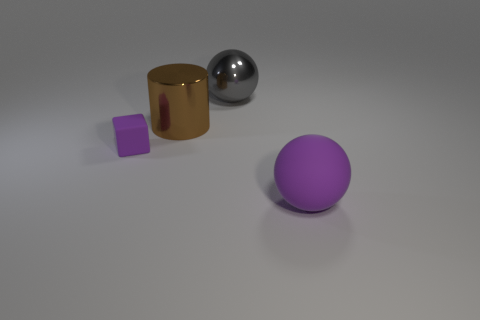Add 1 small rubber objects. How many objects exist? 5 Subtract all cylinders. How many objects are left? 3 Subtract all shiny things. Subtract all rubber things. How many objects are left? 0 Add 2 purple objects. How many purple objects are left? 4 Add 1 tiny purple matte objects. How many tiny purple matte objects exist? 2 Subtract 0 cyan cylinders. How many objects are left? 4 